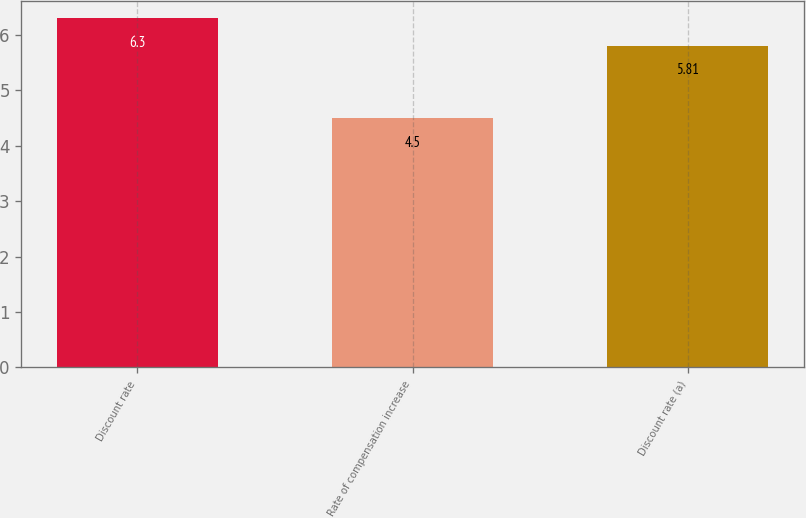<chart> <loc_0><loc_0><loc_500><loc_500><bar_chart><fcel>Discount rate<fcel>Rate of compensation increase<fcel>Discount rate (a)<nl><fcel>6.3<fcel>4.5<fcel>5.81<nl></chart> 